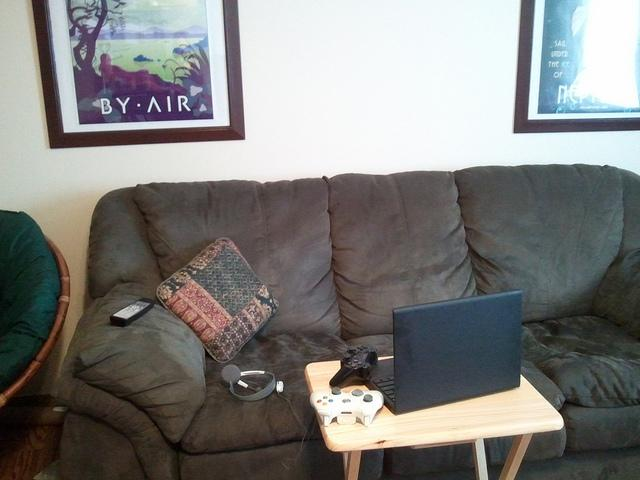Which gaming system is the white remote for on the table? Please explain your reasoning. xbox. The controllers on the wooden folding table are used to play playstation. 